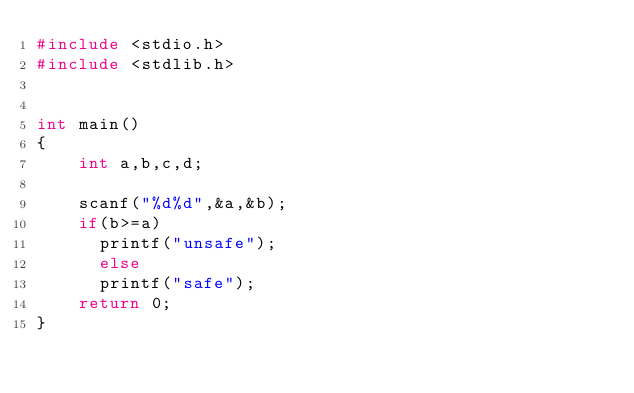Convert code to text. <code><loc_0><loc_0><loc_500><loc_500><_C_>#include <stdio.h>
#include <stdlib.h>


int main() 
{
	int a,b,c,d;
	
	scanf("%d%d",&a,&b);
	if(b>=a)
	  printf("unsafe");
	  else
	  printf("safe");
	return 0;
}
</code> 